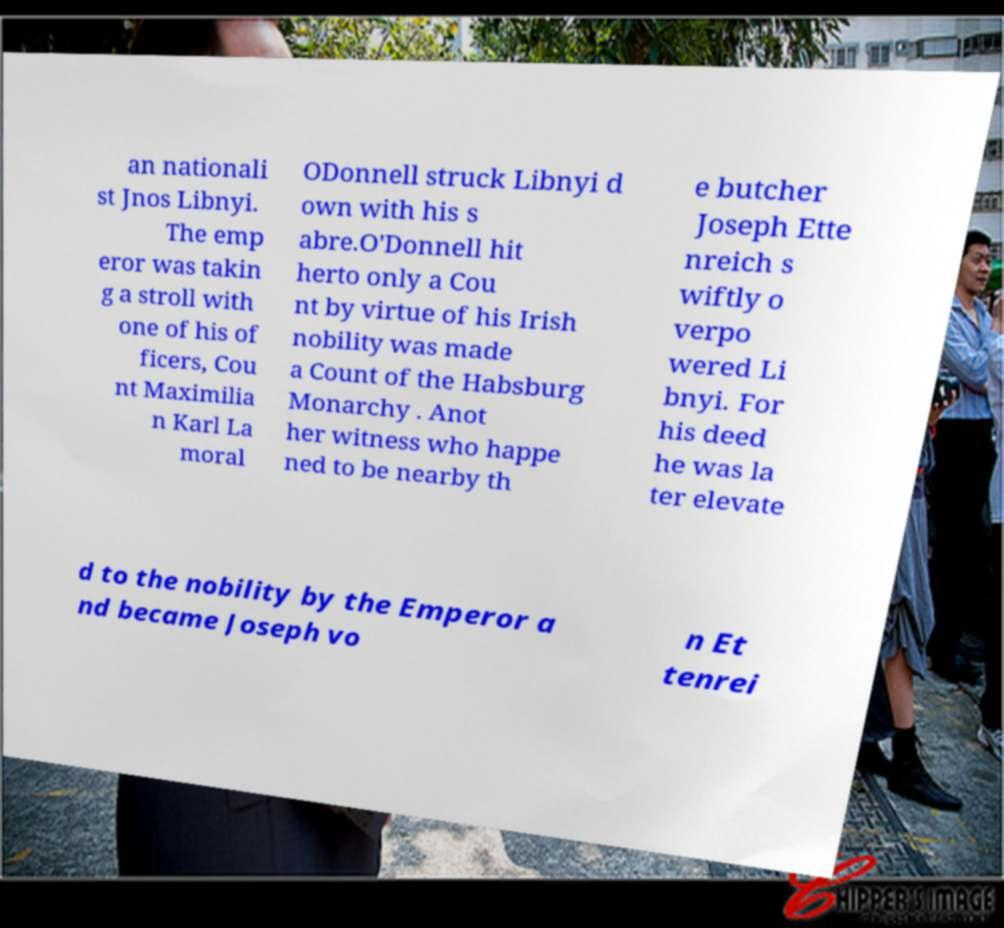Please read and relay the text visible in this image. What does it say? an nationali st Jnos Libnyi. The emp eror was takin g a stroll with one of his of ficers, Cou nt Maximilia n Karl La moral ODonnell struck Libnyi d own with his s abre.O'Donnell hit herto only a Cou nt by virtue of his Irish nobility was made a Count of the Habsburg Monarchy . Anot her witness who happe ned to be nearby th e butcher Joseph Ette nreich s wiftly o verpo wered Li bnyi. For his deed he was la ter elevate d to the nobility by the Emperor a nd became Joseph vo n Et tenrei 